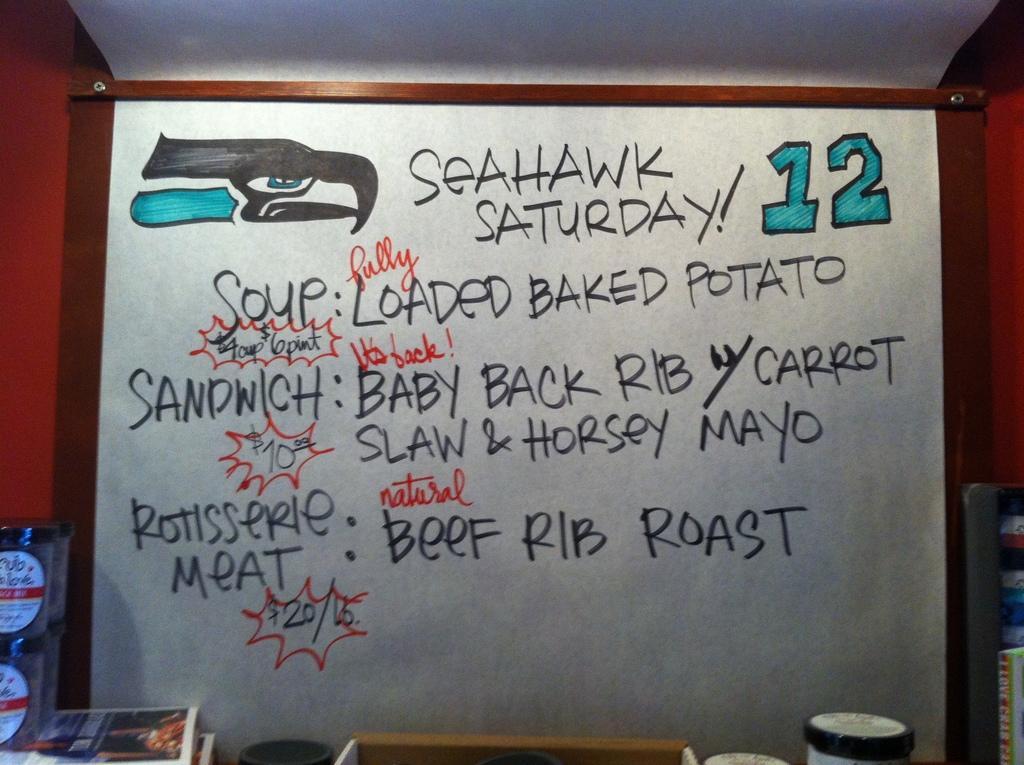In one or two sentences, can you explain what this image depicts? In the foreground of the picture there are books, jars, cup and other objects. In the center of the picture there is a board, on the board there are number, text and drawing. On the top it is ceiling. 